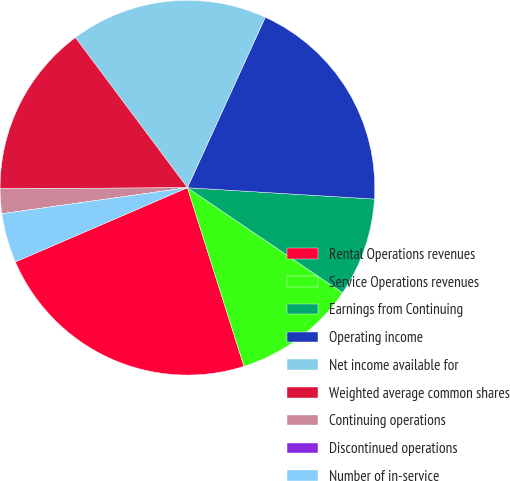<chart> <loc_0><loc_0><loc_500><loc_500><pie_chart><fcel>Rental Operations revenues<fcel>Service Operations revenues<fcel>Earnings from Continuing<fcel>Operating income<fcel>Net income available for<fcel>Weighted average common shares<fcel>Continuing operations<fcel>Discontinued operations<fcel>Number of in-service<nl><fcel>23.4%<fcel>10.64%<fcel>8.51%<fcel>19.15%<fcel>17.02%<fcel>14.89%<fcel>2.13%<fcel>0.0%<fcel>4.26%<nl></chart> 